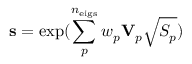Convert formula to latex. <formula><loc_0><loc_0><loc_500><loc_500>s = \exp ( { \sum _ { p } ^ { n _ { e i g s } } w _ { p } V _ { p } \sqrt { S _ { p } } } )</formula> 